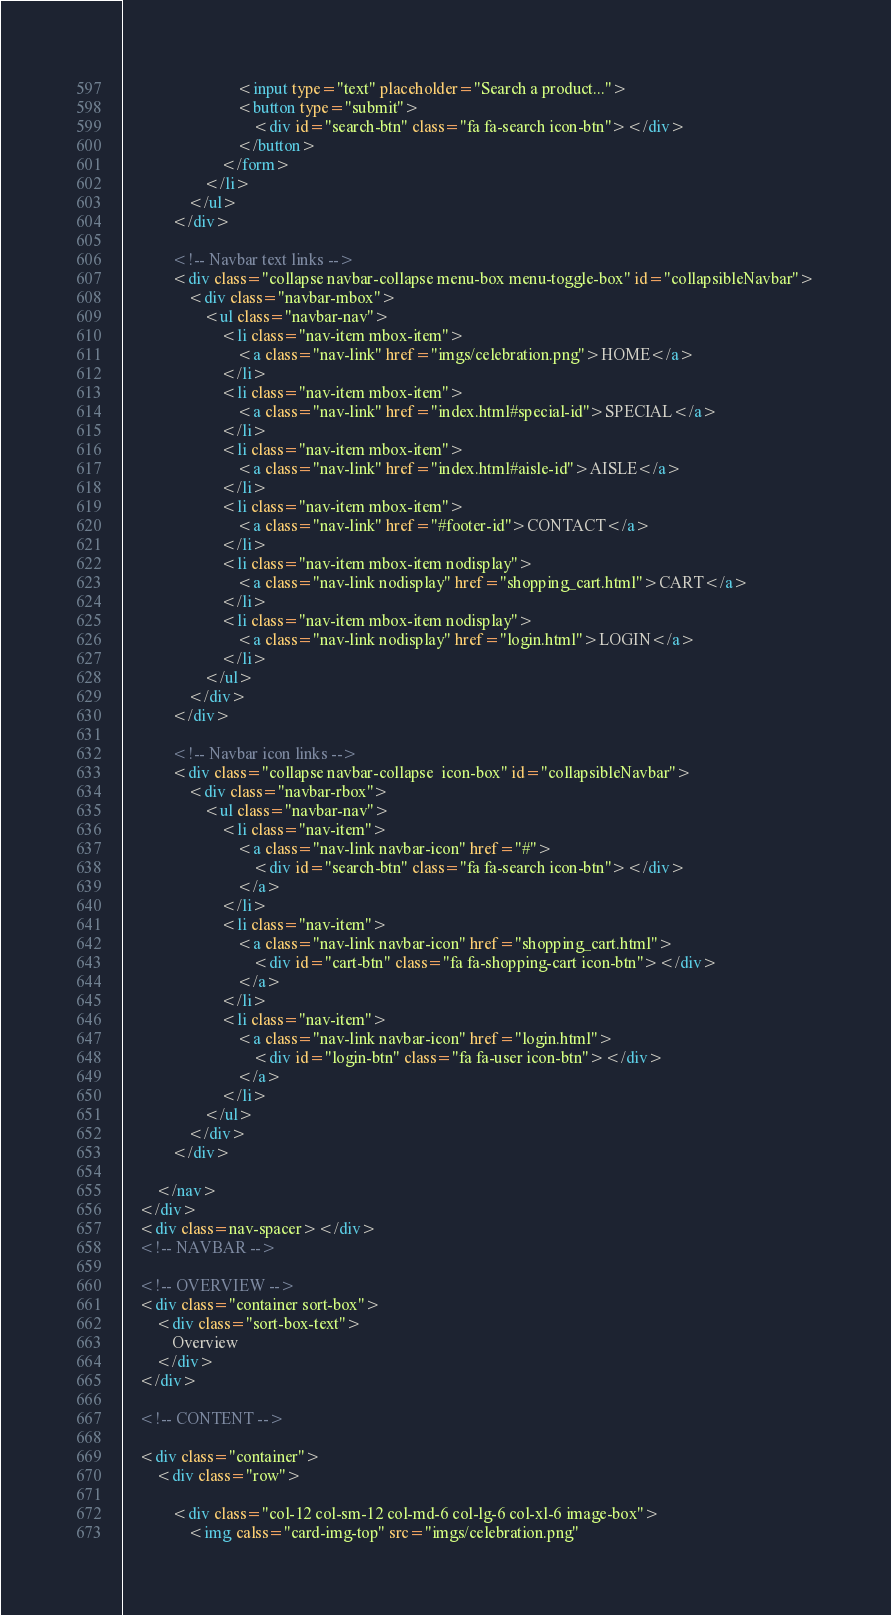<code> <loc_0><loc_0><loc_500><loc_500><_HTML_>                            <input type="text" placeholder="Search a product...">
                            <button type="submit">
                                <div id="search-btn" class="fa fa-search icon-btn"></div>
                            </button>
                        </form>
                    </li>
                </ul>
            </div>

            <!-- Navbar text links -->
            <div class="collapse navbar-collapse menu-box menu-toggle-box" id="collapsibleNavbar">
                <div class="navbar-mbox">
                    <ul class="navbar-nav">
                        <li class="nav-item mbox-item">
                            <a class="nav-link" href="imgs/celebration.png">HOME</a>
                        </li>
                        <li class="nav-item mbox-item">
                            <a class="nav-link" href="index.html#special-id">SPECIAL</a>
                        </li>
                        <li class="nav-item mbox-item">
                            <a class="nav-link" href="index.html#aisle-id">AISLE</a>
                        </li>
                        <li class="nav-item mbox-item">
                            <a class="nav-link" href="#footer-id">CONTACT</a>
                        </li>
                        <li class="nav-item mbox-item nodisplay">
                            <a class="nav-link nodisplay" href="shopping_cart.html">CART</a>
                        </li>
                        <li class="nav-item mbox-item nodisplay">
                            <a class="nav-link nodisplay" href="login.html">LOGIN</a>
                        </li>
                    </ul>
                </div>
            </div>

            <!-- Navbar icon links -->
            <div class="collapse navbar-collapse  icon-box" id="collapsibleNavbar">
                <div class="navbar-rbox">
                    <ul class="navbar-nav">
                        <li class="nav-item">
                            <a class="nav-link navbar-icon" href="#">
                                <div id="search-btn" class="fa fa-search icon-btn"></div>
                            </a>
                        </li>
                        <li class="nav-item">
                            <a class="nav-link navbar-icon" href="shopping_cart.html">
                                <div id="cart-btn" class="fa fa-shopping-cart icon-btn"></div>
                            </a>
                        </li>
                        <li class="nav-item">
                            <a class="nav-link navbar-icon" href="login.html">
                                <div id="login-btn" class="fa fa-user icon-btn"></div>
                            </a>
                        </li>
                    </ul>
                </div>
            </div>

        </nav>
    </div>
    <div class=nav-spacer></div>
    <!-- NAVBAR -->

    <!-- OVERVIEW -->
    <div class="container sort-box">
        <div class="sort-box-text">
            Overview
        </div>
    </div>

    <!-- CONTENT -->

    <div class="container">
        <div class="row">

            <div class="col-12 col-sm-12 col-md-6 col-lg-6 col-xl-6 image-box">
                <img calss="card-img-top" src="imgs/celebration.png"</code> 